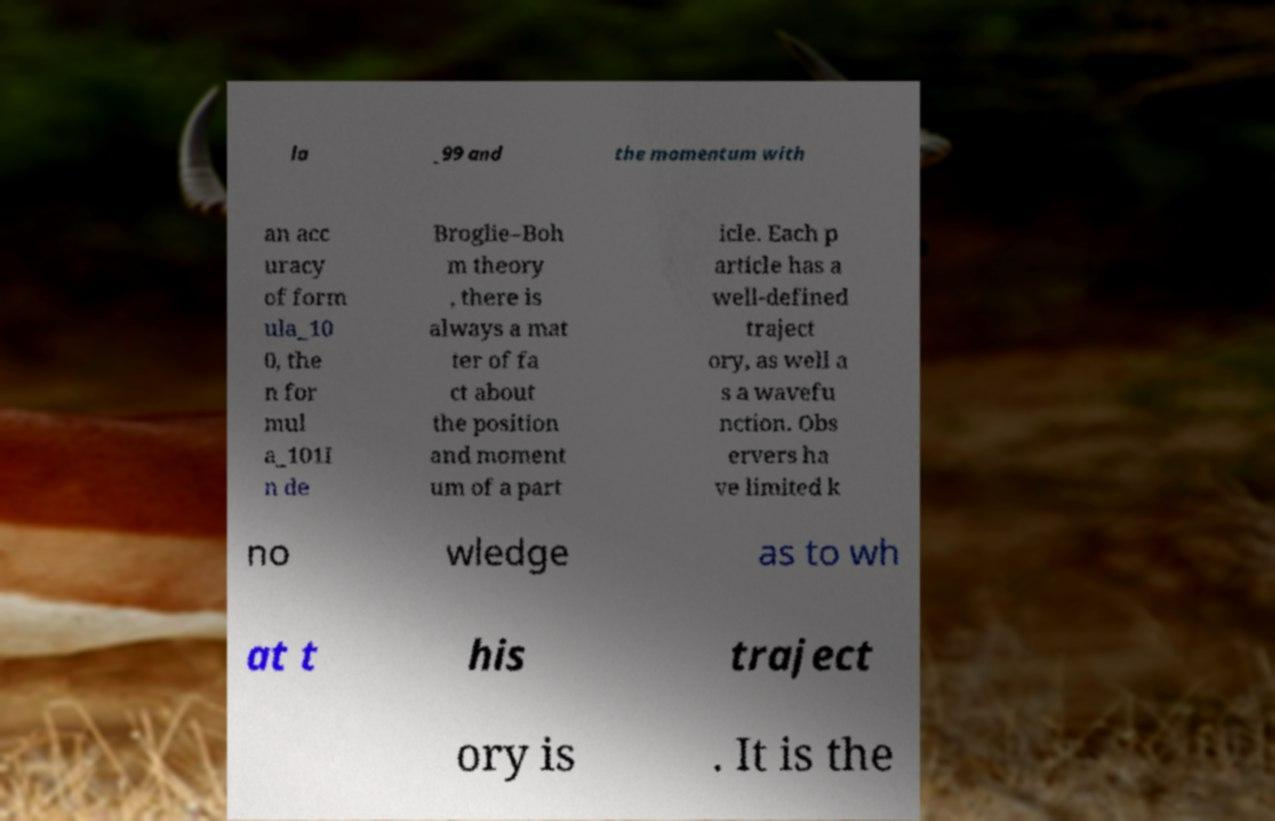For documentation purposes, I need the text within this image transcribed. Could you provide that? la _99 and the momentum with an acc uracy of form ula_10 0, the n for mul a_101I n de Broglie–Boh m theory , there is always a mat ter of fa ct about the position and moment um of a part icle. Each p article has a well-defined traject ory, as well a s a wavefu nction. Obs ervers ha ve limited k no wledge as to wh at t his traject ory is . It is the 